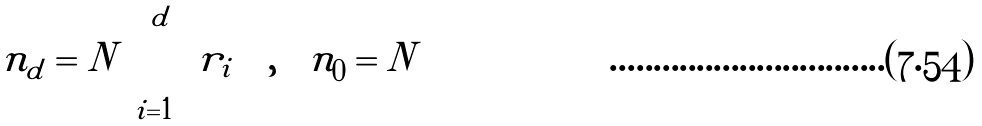<formula> <loc_0><loc_0><loc_500><loc_500>n _ { d } = N \prod _ { i = 1 } ^ { d } r _ { i } \quad , \quad n _ { 0 } = N</formula> 